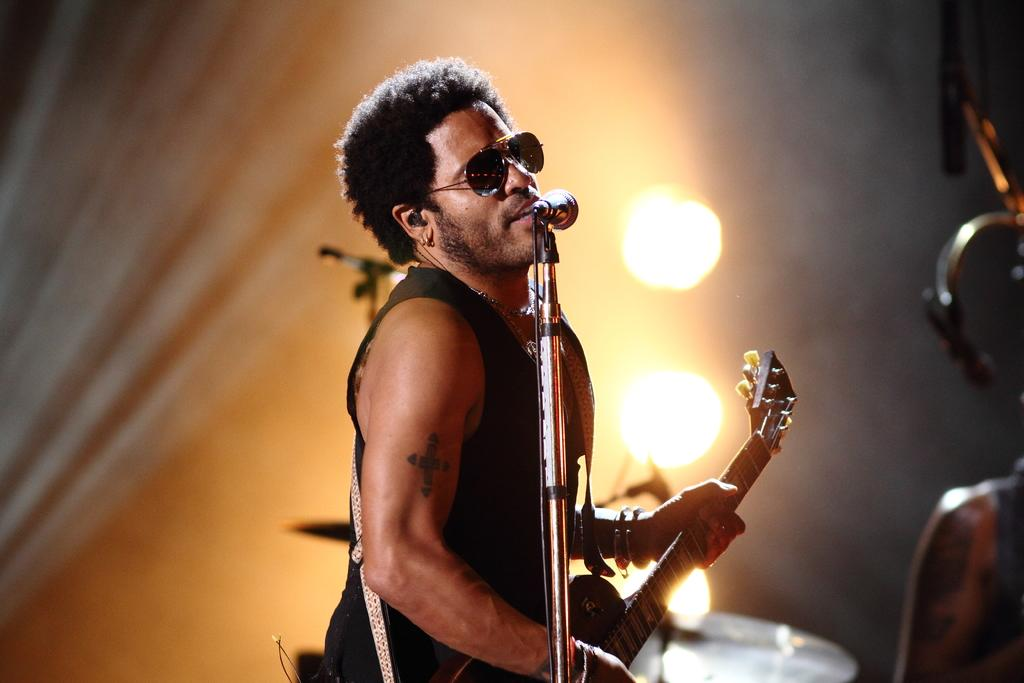What is the main subject of the image? The main subject of the image is a man. What is the man doing in the image? The man is standing and playing a guitar. Is there any equipment near the man? Yes, there is a microphone in front of the man. What is the man doing with the microphone? The man is singing through the microphone. What can be seen in the background of the image? There are show lights in the background of the image. Can you see any ducks quacking in the image? No, there are no ducks present in the image. What type of earth is visible in the image? The image does not show any earth or soil; it features a man playing a guitar and singing through a microphone. 